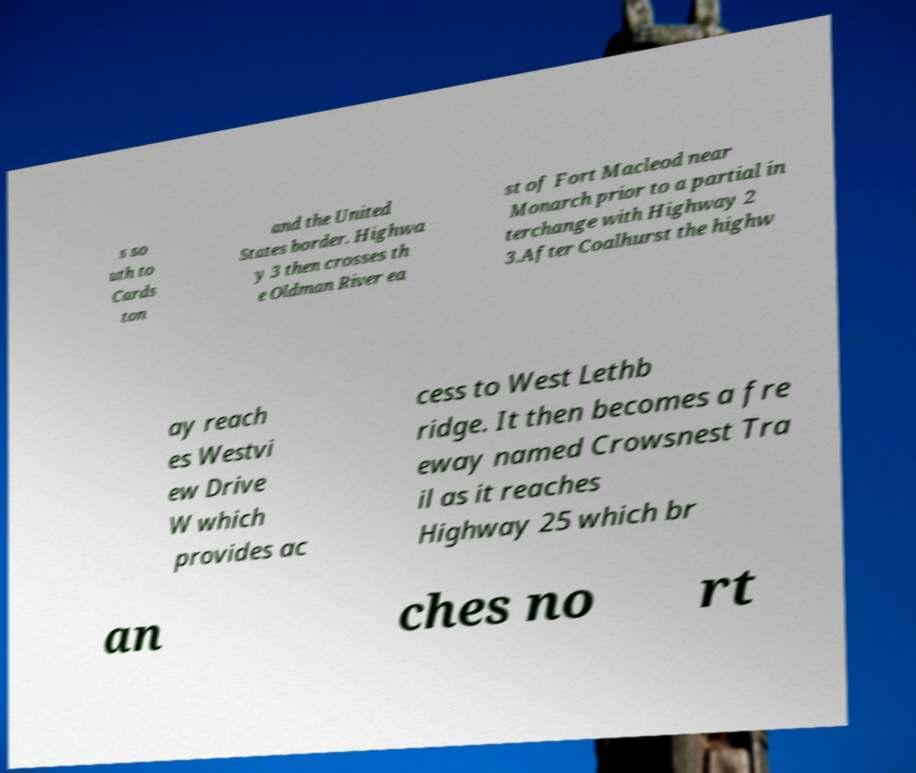Could you assist in decoding the text presented in this image and type it out clearly? s so uth to Cards ton and the United States border. Highwa y 3 then crosses th e Oldman River ea st of Fort Macleod near Monarch prior to a partial in terchange with Highway 2 3.After Coalhurst the highw ay reach es Westvi ew Drive W which provides ac cess to West Lethb ridge. It then becomes a fre eway named Crowsnest Tra il as it reaches Highway 25 which br an ches no rt 